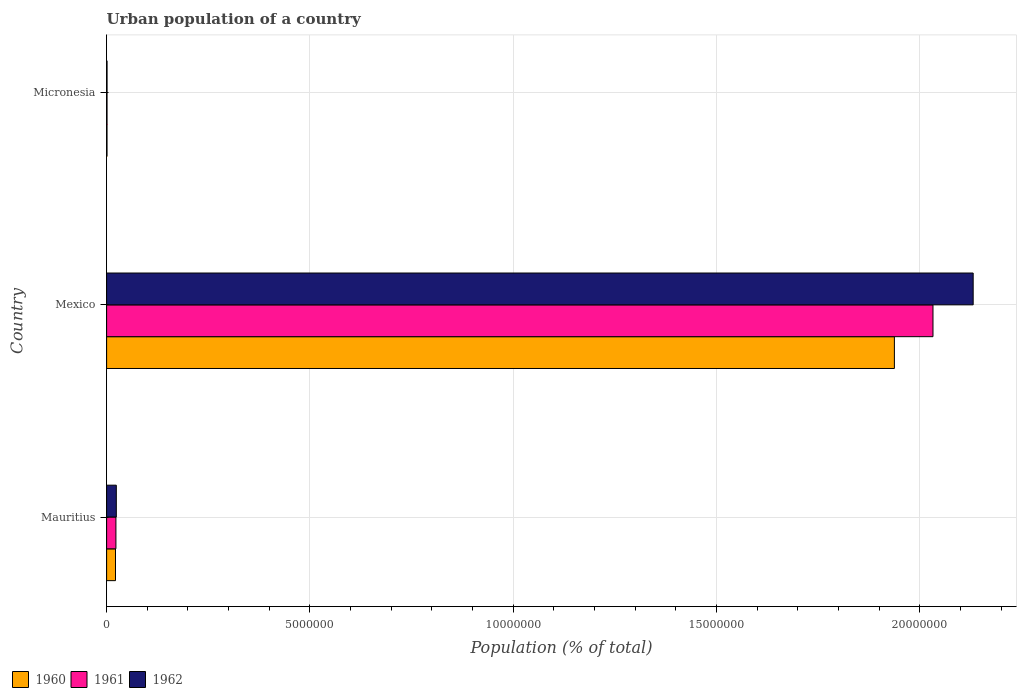How many different coloured bars are there?
Your answer should be compact. 3. How many groups of bars are there?
Give a very brief answer. 3. Are the number of bars per tick equal to the number of legend labels?
Your answer should be very brief. Yes. How many bars are there on the 3rd tick from the bottom?
Ensure brevity in your answer.  3. What is the label of the 3rd group of bars from the top?
Offer a terse response. Mauritius. In how many cases, is the number of bars for a given country not equal to the number of legend labels?
Give a very brief answer. 0. What is the urban population in 1960 in Mauritius?
Provide a succinct answer. 2.19e+05. Across all countries, what is the maximum urban population in 1960?
Offer a terse response. 1.94e+07. Across all countries, what is the minimum urban population in 1962?
Offer a very short reply. 1.08e+04. In which country was the urban population in 1960 maximum?
Your answer should be very brief. Mexico. In which country was the urban population in 1960 minimum?
Provide a succinct answer. Micronesia. What is the total urban population in 1962 in the graph?
Ensure brevity in your answer.  2.16e+07. What is the difference between the urban population in 1962 in Mauritius and that in Micronesia?
Ensure brevity in your answer.  2.28e+05. What is the difference between the urban population in 1962 in Mauritius and the urban population in 1960 in Micronesia?
Your answer should be compact. 2.29e+05. What is the average urban population in 1962 per country?
Keep it short and to the point. 7.19e+06. What is the difference between the urban population in 1960 and urban population in 1962 in Mauritius?
Offer a very short reply. -2.01e+04. In how many countries, is the urban population in 1960 greater than 19000000 %?
Ensure brevity in your answer.  1. What is the ratio of the urban population in 1960 in Mexico to that in Micronesia?
Make the answer very short. 1949.54. Is the urban population in 1962 in Mauritius less than that in Mexico?
Make the answer very short. Yes. What is the difference between the highest and the second highest urban population in 1962?
Make the answer very short. 2.11e+07. What is the difference between the highest and the lowest urban population in 1962?
Your answer should be compact. 2.13e+07. In how many countries, is the urban population in 1962 greater than the average urban population in 1962 taken over all countries?
Give a very brief answer. 1. Is the sum of the urban population in 1962 in Mexico and Micronesia greater than the maximum urban population in 1961 across all countries?
Ensure brevity in your answer.  Yes. Is it the case that in every country, the sum of the urban population in 1961 and urban population in 1962 is greater than the urban population in 1960?
Provide a short and direct response. Yes. Are all the bars in the graph horizontal?
Offer a very short reply. Yes. Are the values on the major ticks of X-axis written in scientific E-notation?
Offer a very short reply. No. Does the graph contain any zero values?
Keep it short and to the point. No. Does the graph contain grids?
Keep it short and to the point. Yes. How are the legend labels stacked?
Offer a very short reply. Horizontal. What is the title of the graph?
Offer a very short reply. Urban population of a country. What is the label or title of the X-axis?
Keep it short and to the point. Population (% of total). What is the label or title of the Y-axis?
Provide a succinct answer. Country. What is the Population (% of total) of 1960 in Mauritius?
Your answer should be very brief. 2.19e+05. What is the Population (% of total) of 1961 in Mauritius?
Provide a short and direct response. 2.29e+05. What is the Population (% of total) in 1962 in Mauritius?
Make the answer very short. 2.39e+05. What is the Population (% of total) in 1960 in Mexico?
Provide a short and direct response. 1.94e+07. What is the Population (% of total) of 1961 in Mexico?
Your answer should be compact. 2.03e+07. What is the Population (% of total) of 1962 in Mexico?
Your answer should be compact. 2.13e+07. What is the Population (% of total) of 1960 in Micronesia?
Your response must be concise. 9938. What is the Population (% of total) of 1961 in Micronesia?
Give a very brief answer. 1.04e+04. What is the Population (% of total) in 1962 in Micronesia?
Offer a terse response. 1.08e+04. Across all countries, what is the maximum Population (% of total) in 1960?
Make the answer very short. 1.94e+07. Across all countries, what is the maximum Population (% of total) in 1961?
Keep it short and to the point. 2.03e+07. Across all countries, what is the maximum Population (% of total) in 1962?
Give a very brief answer. 2.13e+07. Across all countries, what is the minimum Population (% of total) in 1960?
Give a very brief answer. 9938. Across all countries, what is the minimum Population (% of total) of 1961?
Keep it short and to the point. 1.04e+04. Across all countries, what is the minimum Population (% of total) of 1962?
Give a very brief answer. 1.08e+04. What is the total Population (% of total) of 1960 in the graph?
Your answer should be compact. 1.96e+07. What is the total Population (% of total) in 1961 in the graph?
Your answer should be compact. 2.06e+07. What is the total Population (% of total) of 1962 in the graph?
Provide a succinct answer. 2.16e+07. What is the difference between the Population (% of total) of 1960 in Mauritius and that in Mexico?
Offer a terse response. -1.92e+07. What is the difference between the Population (% of total) of 1961 in Mauritius and that in Mexico?
Your response must be concise. -2.01e+07. What is the difference between the Population (% of total) of 1962 in Mauritius and that in Mexico?
Offer a terse response. -2.11e+07. What is the difference between the Population (% of total) of 1960 in Mauritius and that in Micronesia?
Give a very brief answer. 2.09e+05. What is the difference between the Population (% of total) of 1961 in Mauritius and that in Micronesia?
Your answer should be compact. 2.19e+05. What is the difference between the Population (% of total) in 1962 in Mauritius and that in Micronesia?
Provide a succinct answer. 2.28e+05. What is the difference between the Population (% of total) in 1960 in Mexico and that in Micronesia?
Ensure brevity in your answer.  1.94e+07. What is the difference between the Population (% of total) of 1961 in Mexico and that in Micronesia?
Offer a terse response. 2.03e+07. What is the difference between the Population (% of total) of 1962 in Mexico and that in Micronesia?
Offer a very short reply. 2.13e+07. What is the difference between the Population (% of total) of 1960 in Mauritius and the Population (% of total) of 1961 in Mexico?
Ensure brevity in your answer.  -2.01e+07. What is the difference between the Population (% of total) of 1960 in Mauritius and the Population (% of total) of 1962 in Mexico?
Offer a terse response. -2.11e+07. What is the difference between the Population (% of total) of 1961 in Mauritius and the Population (% of total) of 1962 in Mexico?
Provide a short and direct response. -2.11e+07. What is the difference between the Population (% of total) of 1960 in Mauritius and the Population (% of total) of 1961 in Micronesia?
Your response must be concise. 2.08e+05. What is the difference between the Population (% of total) in 1960 in Mauritius and the Population (% of total) in 1962 in Micronesia?
Provide a succinct answer. 2.08e+05. What is the difference between the Population (% of total) of 1961 in Mauritius and the Population (% of total) of 1962 in Micronesia?
Keep it short and to the point. 2.18e+05. What is the difference between the Population (% of total) in 1960 in Mexico and the Population (% of total) in 1961 in Micronesia?
Your answer should be very brief. 1.94e+07. What is the difference between the Population (% of total) of 1960 in Mexico and the Population (% of total) of 1962 in Micronesia?
Your answer should be very brief. 1.94e+07. What is the difference between the Population (% of total) of 1961 in Mexico and the Population (% of total) of 1962 in Micronesia?
Make the answer very short. 2.03e+07. What is the average Population (% of total) of 1960 per country?
Keep it short and to the point. 6.53e+06. What is the average Population (% of total) in 1961 per country?
Keep it short and to the point. 6.85e+06. What is the average Population (% of total) in 1962 per country?
Keep it short and to the point. 7.19e+06. What is the difference between the Population (% of total) of 1960 and Population (% of total) of 1961 in Mauritius?
Ensure brevity in your answer.  -1.02e+04. What is the difference between the Population (% of total) of 1960 and Population (% of total) of 1962 in Mauritius?
Offer a very short reply. -2.01e+04. What is the difference between the Population (% of total) in 1961 and Population (% of total) in 1962 in Mauritius?
Give a very brief answer. -9854. What is the difference between the Population (% of total) in 1960 and Population (% of total) in 1961 in Mexico?
Give a very brief answer. -9.49e+05. What is the difference between the Population (% of total) of 1960 and Population (% of total) of 1962 in Mexico?
Provide a short and direct response. -1.94e+06. What is the difference between the Population (% of total) in 1961 and Population (% of total) in 1962 in Mexico?
Give a very brief answer. -9.88e+05. What is the difference between the Population (% of total) in 1960 and Population (% of total) in 1961 in Micronesia?
Provide a short and direct response. -426. What is the difference between the Population (% of total) of 1960 and Population (% of total) of 1962 in Micronesia?
Offer a very short reply. -865. What is the difference between the Population (% of total) of 1961 and Population (% of total) of 1962 in Micronesia?
Provide a succinct answer. -439. What is the ratio of the Population (% of total) of 1960 in Mauritius to that in Mexico?
Keep it short and to the point. 0.01. What is the ratio of the Population (% of total) of 1961 in Mauritius to that in Mexico?
Offer a terse response. 0.01. What is the ratio of the Population (% of total) of 1962 in Mauritius to that in Mexico?
Your response must be concise. 0.01. What is the ratio of the Population (% of total) in 1960 in Mauritius to that in Micronesia?
Offer a terse response. 22.01. What is the ratio of the Population (% of total) of 1961 in Mauritius to that in Micronesia?
Your answer should be compact. 22.09. What is the ratio of the Population (% of total) in 1962 in Mauritius to that in Micronesia?
Offer a very short reply. 22.11. What is the ratio of the Population (% of total) of 1960 in Mexico to that in Micronesia?
Your answer should be compact. 1949.54. What is the ratio of the Population (% of total) in 1961 in Mexico to that in Micronesia?
Offer a very short reply. 1960.96. What is the ratio of the Population (% of total) in 1962 in Mexico to that in Micronesia?
Ensure brevity in your answer.  1972.76. What is the difference between the highest and the second highest Population (% of total) of 1960?
Provide a succinct answer. 1.92e+07. What is the difference between the highest and the second highest Population (% of total) in 1961?
Provide a short and direct response. 2.01e+07. What is the difference between the highest and the second highest Population (% of total) in 1962?
Your answer should be very brief. 2.11e+07. What is the difference between the highest and the lowest Population (% of total) in 1960?
Provide a short and direct response. 1.94e+07. What is the difference between the highest and the lowest Population (% of total) of 1961?
Offer a terse response. 2.03e+07. What is the difference between the highest and the lowest Population (% of total) of 1962?
Provide a succinct answer. 2.13e+07. 